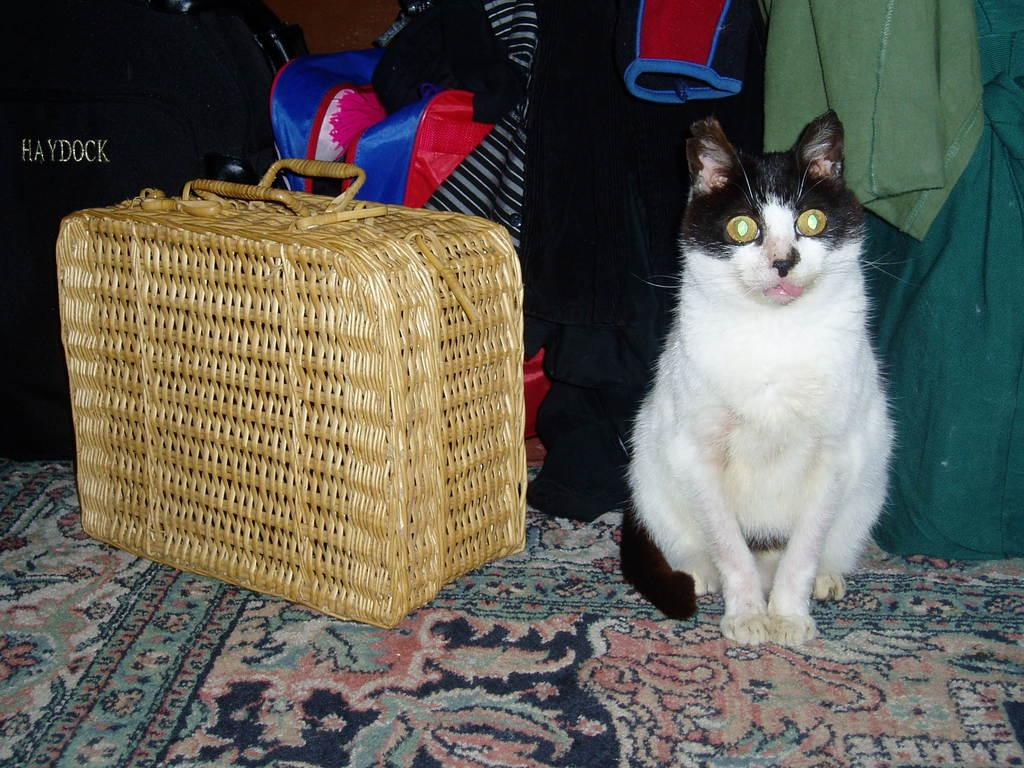What type of animal is in the image? There is a black and white cat in the image. What object is beside the cat? There is a suitcase beside the cat. What can be seen in the background of the image? Clothes and bags are present in the background of the image. What is at the bottom of the image? There is a carpet at the bottom of the image. Where is the store located in the image? There is no store present in the image. What is the cat dropping off the edge of the suitcase in the image? The cat is not dropping anything off the edge of the suitcase in the image; it is simply sitting beside it. 